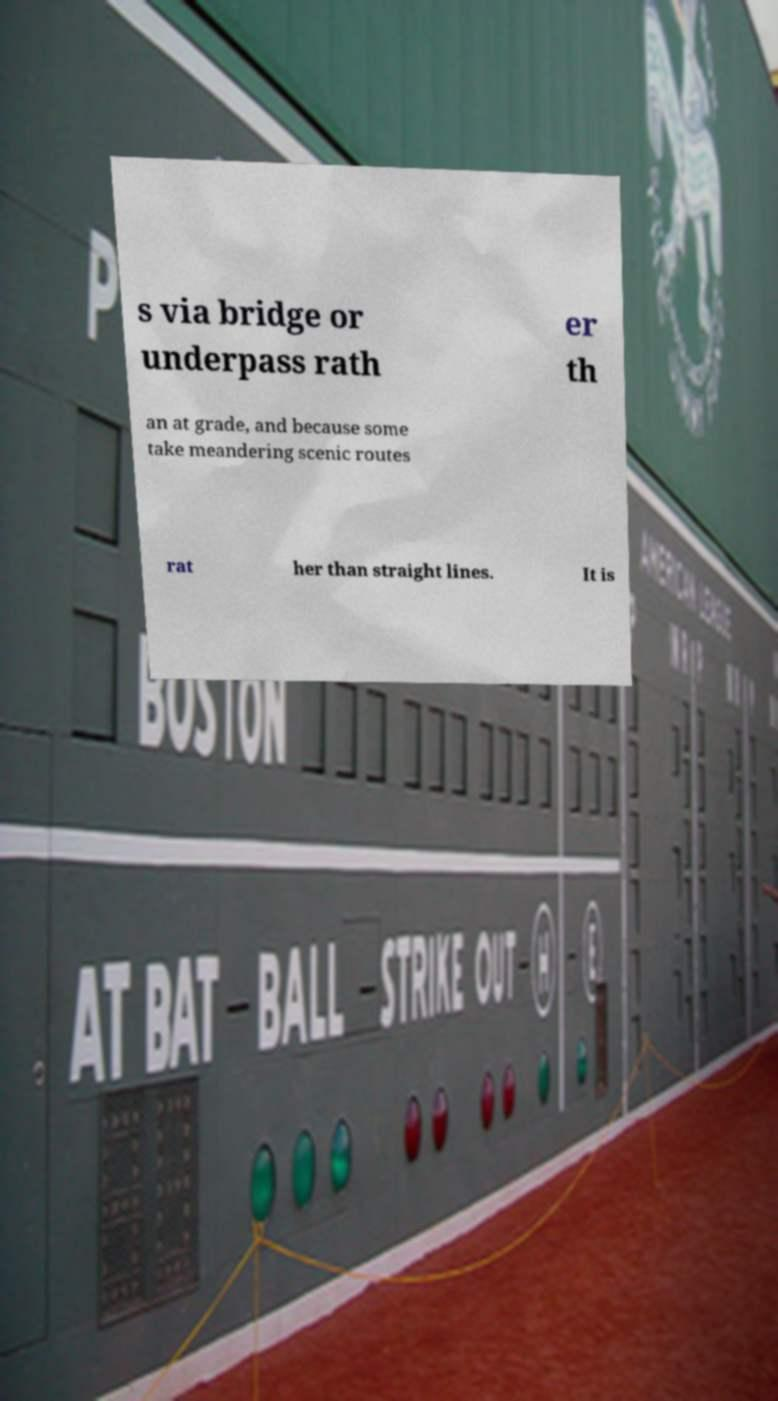Please identify and transcribe the text found in this image. s via bridge or underpass rath er th an at grade, and because some take meandering scenic routes rat her than straight lines. It is 